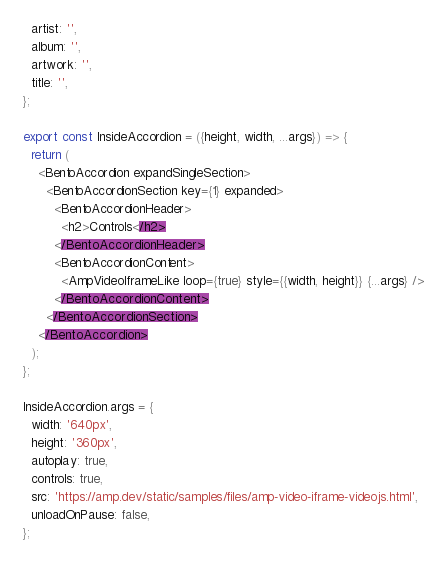Convert code to text. <code><loc_0><loc_0><loc_500><loc_500><_JavaScript_>  artist: '',
  album: '',
  artwork: '',
  title: '',
};

export const InsideAccordion = ({height, width, ...args}) => {
  return (
    <BentoAccordion expandSingleSection>
      <BentoAccordionSection key={1} expanded>
        <BentoAccordionHeader>
          <h2>Controls</h2>
        </BentoAccordionHeader>
        <BentoAccordionContent>
          <AmpVideoIframeLike loop={true} style={{width, height}} {...args} />
        </BentoAccordionContent>
      </BentoAccordionSection>
    </BentoAccordion>
  );
};

InsideAccordion.args = {
  width: '640px',
  height: '360px',
  autoplay: true,
  controls: true,
  src: 'https://amp.dev/static/samples/files/amp-video-iframe-videojs.html',
  unloadOnPause: false,
};
</code> 